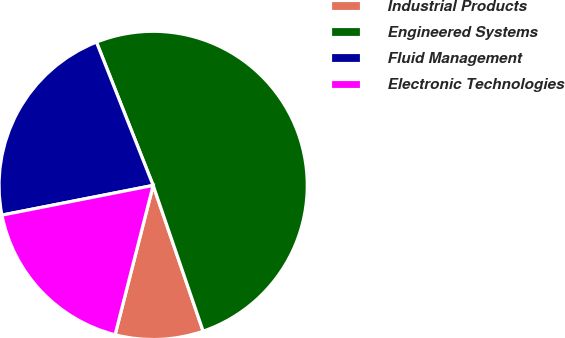Convert chart to OTSL. <chart><loc_0><loc_0><loc_500><loc_500><pie_chart><fcel>Industrial Products<fcel>Engineered Systems<fcel>Fluid Management<fcel>Electronic Technologies<nl><fcel>9.23%<fcel>50.74%<fcel>22.09%<fcel>17.94%<nl></chart> 